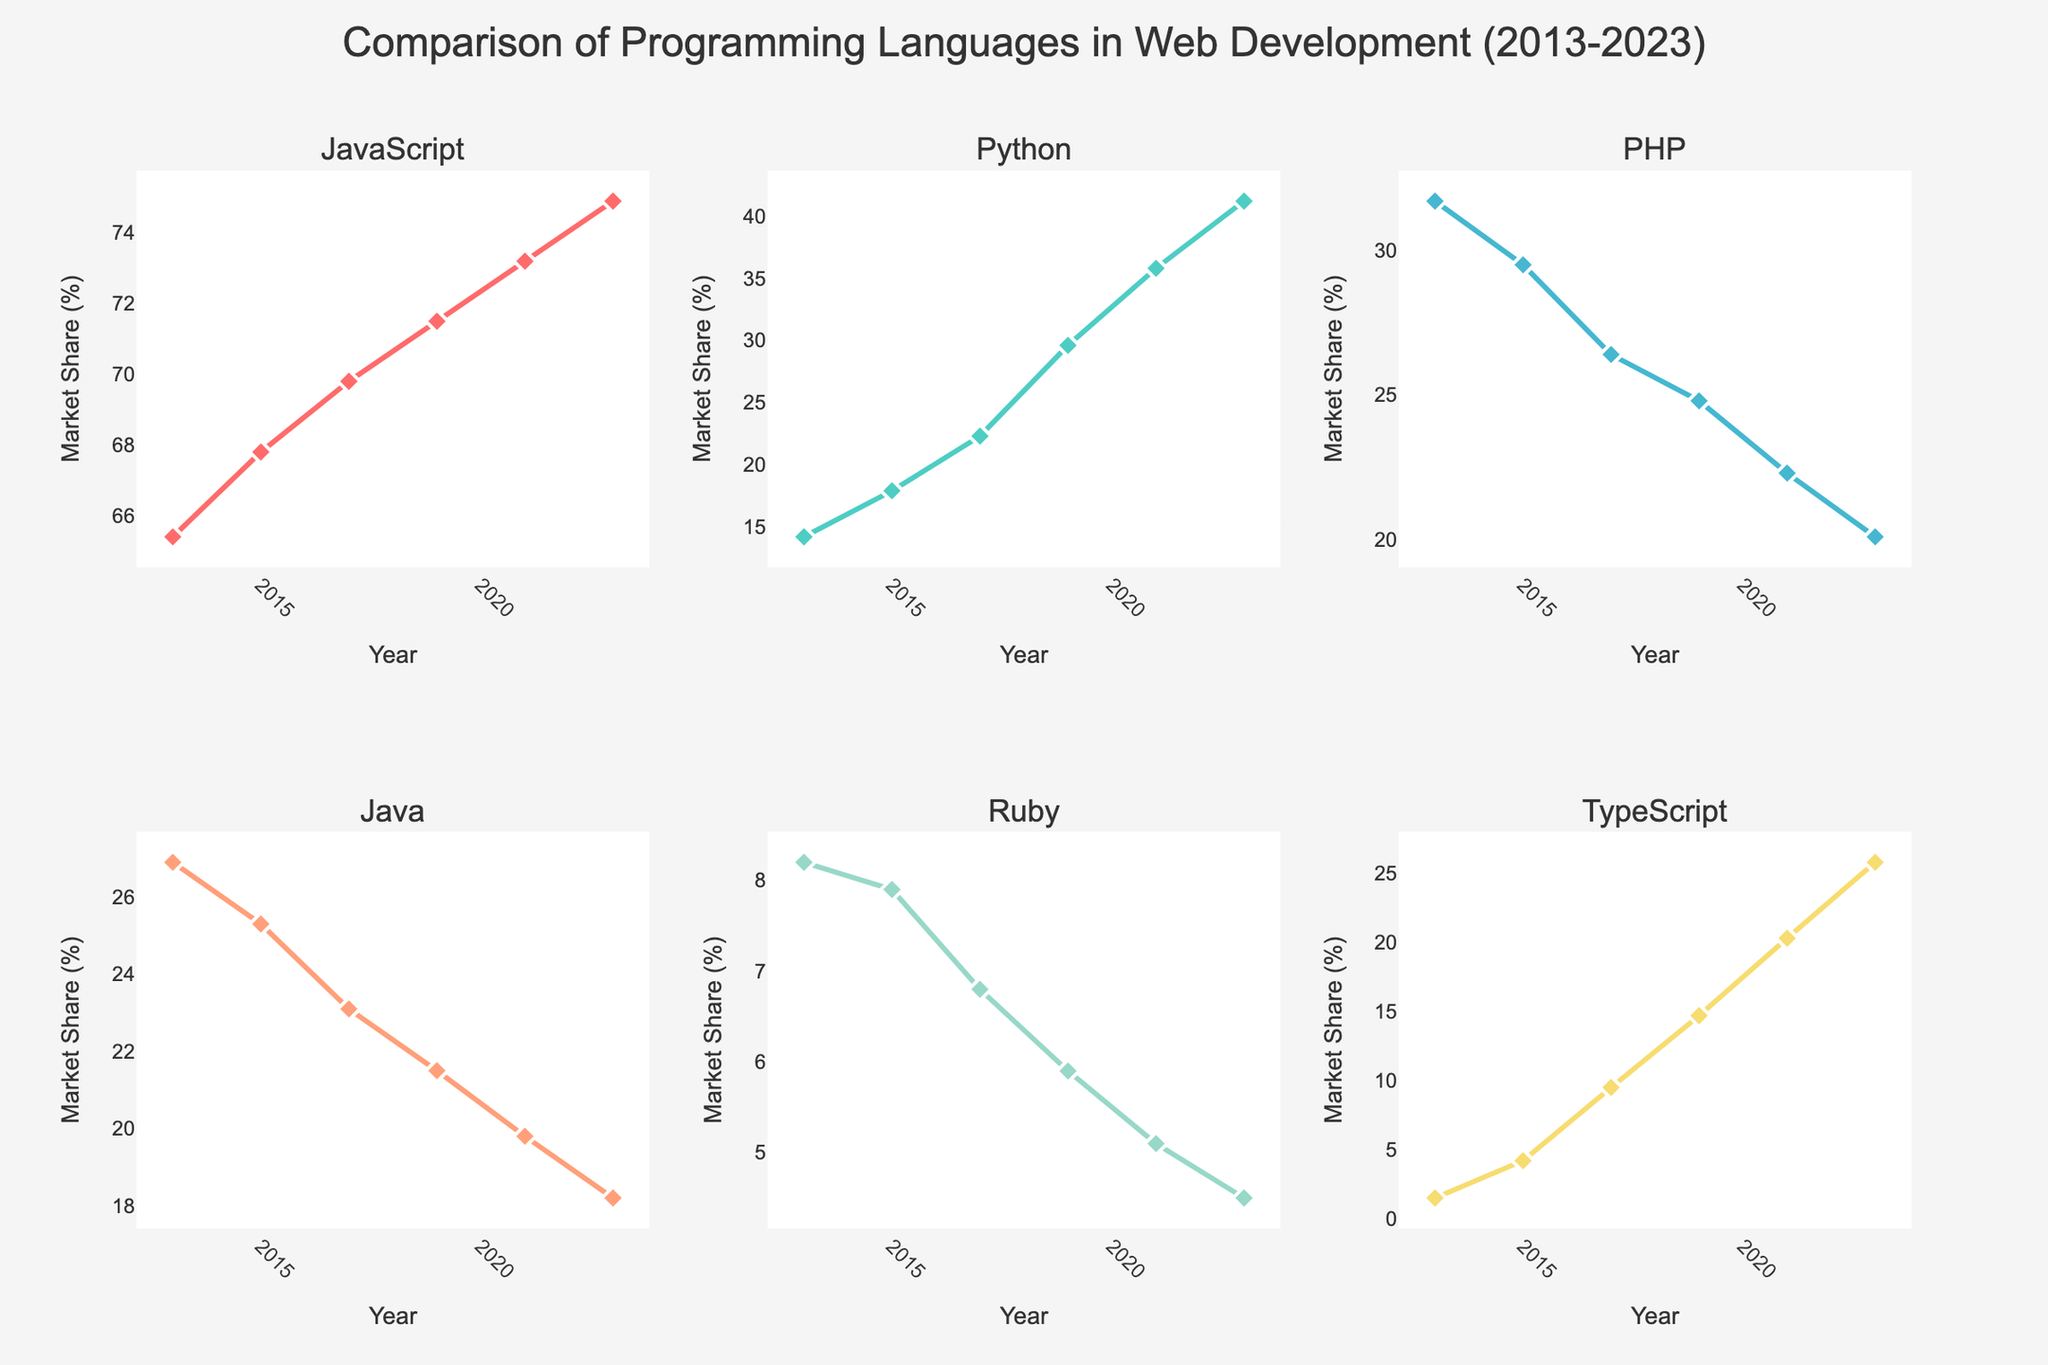How does the market share of JavaScript change from 2013 to 2023? To determine how the market share of JavaScript changes over the years, look at the line plot for JavaScript in the figure. It shows an increase from 65.4% in 2013 to 74.9% in 2023.
Answer: It increased Which programming language saw the most significant increase in market share between 2013 and 2023? To find the language with the most significant increase in market share, compare the initial and final values for each language. Python increased from 14.2% to 41.2%, which is the largest increase among the languages shown.
Answer: Python In which year did TypeScript surpass Ruby in market share? Look for the year on the TypeScript and Ruby plots where TypeScript's market share value becomes greater than Ruby's. This happened in 2017 when TypeScript had a market share of 9.5%, surpassing Ruby's 6.8%.
Answer: 2017 Compare the trend of PHP and Java market shares over the decade. The trends for PHP and Java follow a similar decreasing pattern from 2013 to 2023. PHP dropped from 31.7% to 20.1%, and Java from 26.9% to 18.2%.
Answer: Both decreased By how much did Python's market share grow from 2015 to 2019? Look at the Python plot for 2015 and 2019. The market share grew from 17.9% to 29.6%. Subtract 17.9 from 29.6 to find the increase: 29.6 - 17.9 = 11.7%.
Answer: 11.7% Which language had the lowest market share growth in the given decade? Analyze the increase in market share for each language. Ruby increased the least, going from 8.2% in 2013 to 4.5% in 2023, which is actually a decrease.
Answer: Ruby What was the market share of TypeScript in 2021 and how does it compare with PHP's share in the same year? Check the plot for 2021: TypeScript's market share was 20.3%, while PHP's was 22.3%. TypeScript's share was slightly less than PHP's by 2%.
Answer: Less by 2% Which three languages saw consistent growth every year between 2013 and 2023? Review each language's plot and ensure the market share increases or remains stable every year. JavaScript, Python, and TypeScript consistently increased over this period.
Answer: JavaScript, Python, TypeScript Identify the year in which Java's market share first dropped below 20%. Check Java's plot for the given years. Java's market share first dropped below 20% in 2021.
Answer: 2021 